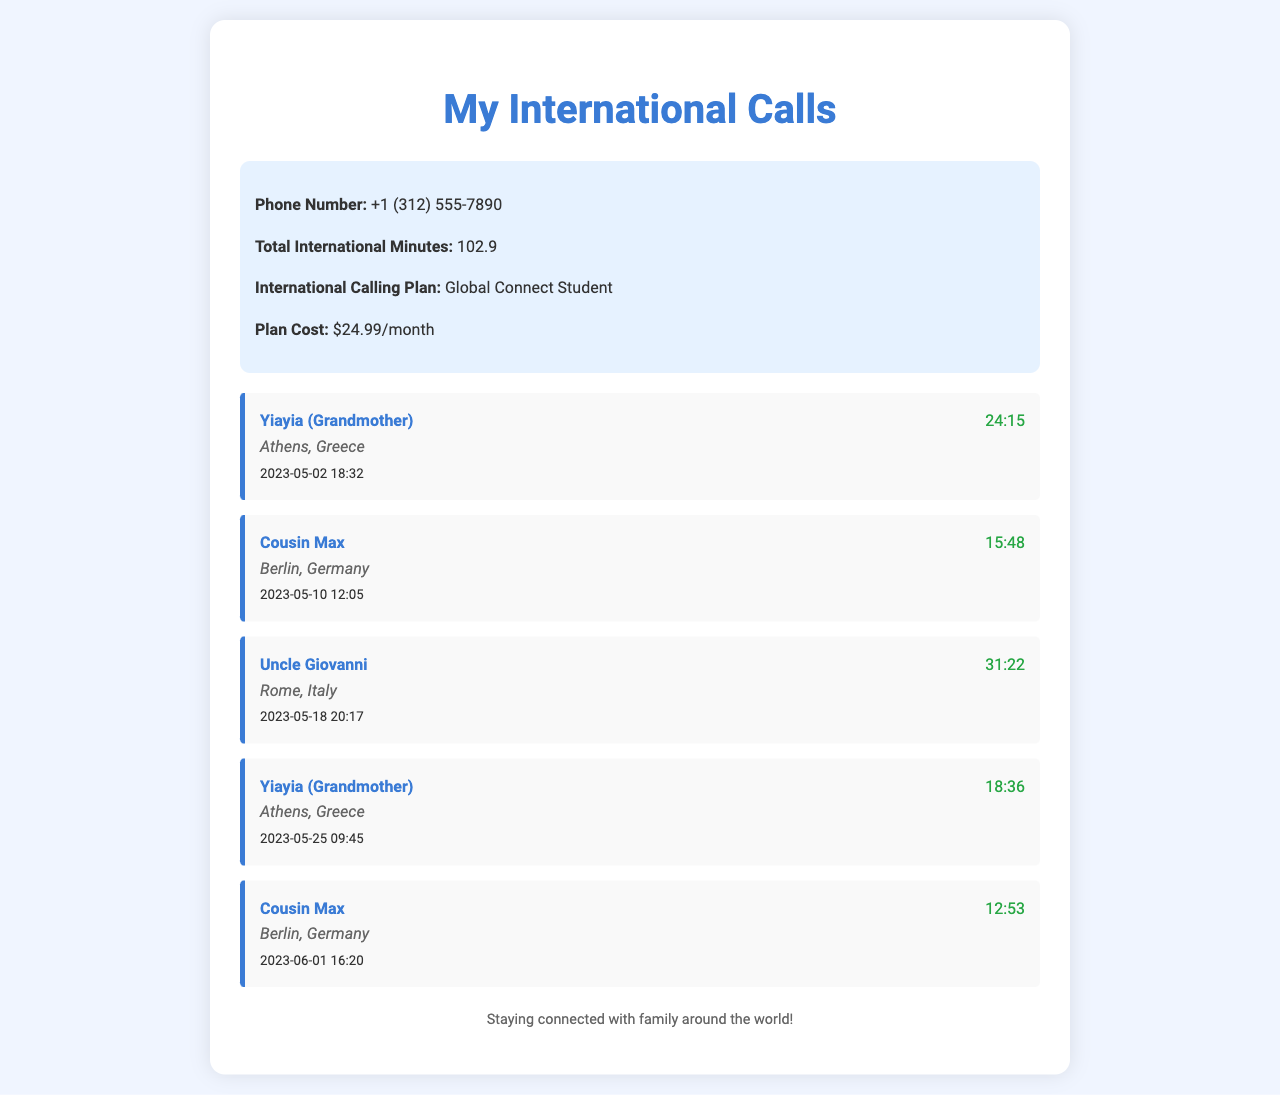what is the phone number listed? The phone number listed under the summary is the personal phone number of the user, which is +1 (312) 555-7890.
Answer: +1 (312) 555-7890 how many total international minutes are recorded? The total international minutes are provided in the summary, indicating the time spent on international calls, which is 102.9 minutes.
Answer: 102.9 what is the name of the first contact? The first contact in the call records is mentioned with the title "Yiayia," which means grandmother in Greek, indicating a family relationship.
Answer: Yiayia (Grandmother) what country does Uncle Giovanni live in? Uncle Giovanni's location is indicated with the mention of Rome, which is the capital of Italy, showing the country he resides in.
Answer: Italy how long was the longest call? The call duration is recorded for each call, and the longest call listed is with Uncle Giovanni, which was 31 minutes and 22 seconds long.
Answer: 31:22 how many times was Yiayia called? The entries show there are two calls made to Yiayia, demonstrating the frequency of contact with this family member.
Answer: 2 what is the name of the contact in Berlin? The call records feature a contact named Cousin Max, who is located in Berlin, providing insight into the family connections.
Answer: Cousin Max which international calling plan is used? The summary indicates the specific plan used for international calls, which is named Global Connect Student, giving details about the service chosen.
Answer: Global Connect Student 